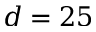Convert formula to latex. <formula><loc_0><loc_0><loc_500><loc_500>d = 2 5</formula> 